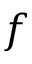<formula> <loc_0><loc_0><loc_500><loc_500>f</formula> 